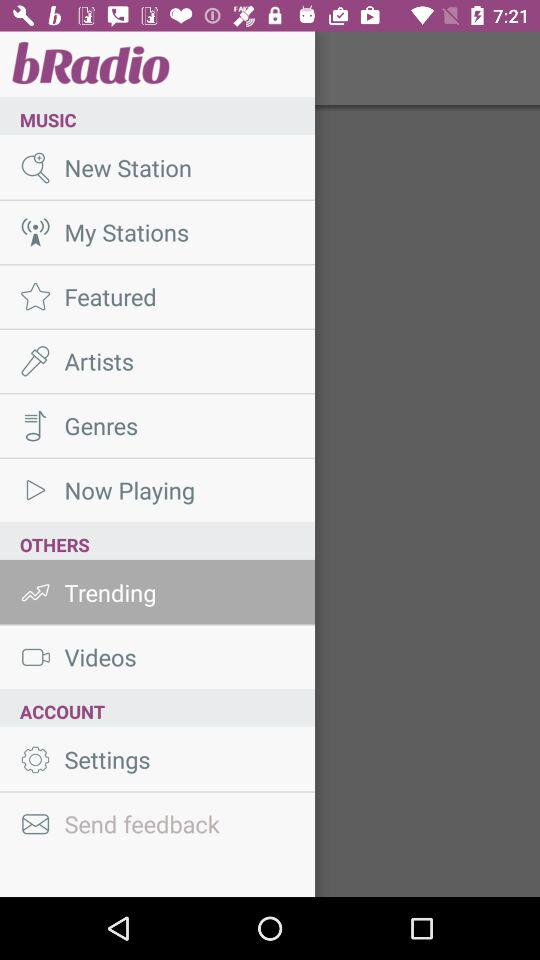How many items are in the 'MUSIC' section?
Answer the question using a single word or phrase. 6 